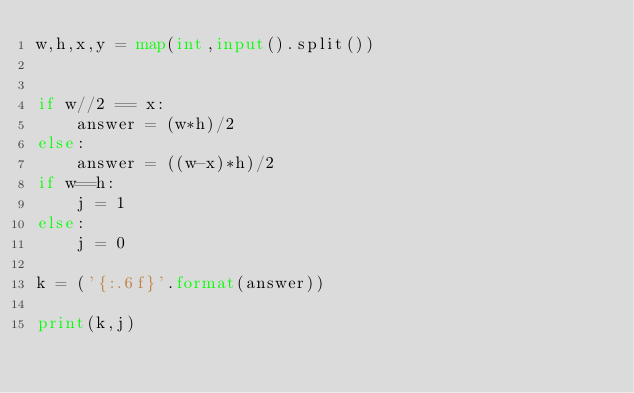Convert code to text. <code><loc_0><loc_0><loc_500><loc_500><_Python_>w,h,x,y = map(int,input().split())


if w//2 == x: 
    answer = (w*h)/2
else:
    answer = ((w-x)*h)/2
if w==h:
    j = 1
else:
    j = 0
    
k = ('{:.6f}'.format(answer))    

print(k,j)</code> 